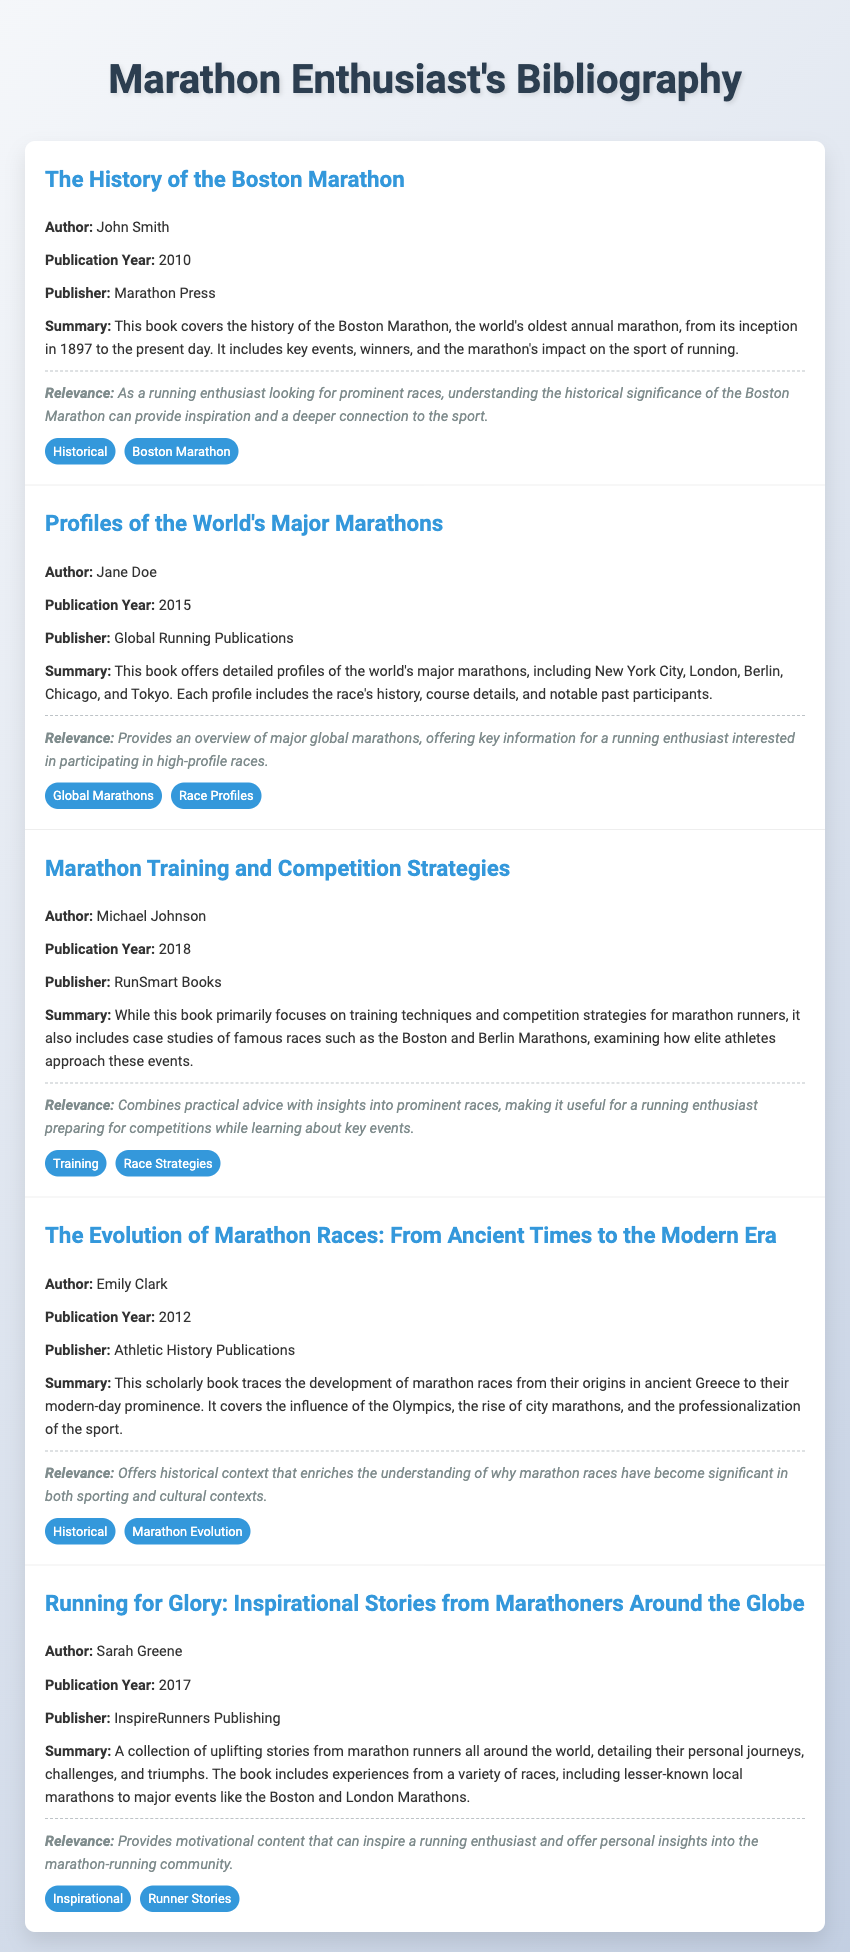What is the title of the first entry? The title of the first entry is found in the document, and it is "The History of the Boston Marathon."
Answer: The History of the Boston Marathon Who is the author of the book published in 2015? The author of the 2015 publication can be found in the second entry of the document, which lists Jane Doe as the author.
Answer: Jane Doe What year was "Marathon Training and Competition Strategies" published? The publication year of this book is explicitly mentioned in the document as 2018.
Answer: 2018 How many major marathons are detailed in "Profiles of the World's Major Marathons"? The document indicates that this book covers several major marathons but specifically mentions "New York City, London, Berlin, Chicago, and Tokyo," which counts as five.
Answer: Five What theme does "Running for Glory" focus on? The theme of this book is clearly indicated in the summary, focusing on personal journeys, challenges, and triumphs of marathon runners, thus it can be summarized as "Inspirational Stories."
Answer: Inspirational Stories Which entry discusses the evolution of marathons? The document specifies that "The Evolution of Marathon Races: From Ancient Times to the Modern Era" discusses the historical development of marathon races.
Answer: The Evolution of Marathon Races: From Ancient Times to the Modern Era What is the relevance of the book "Marathon Training and Competition Strategies"? The relevance section provides insights on how this book combines advice with insights into prominent races, making it relevant for preparation for competitions.
Answer: Useful for a running enthusiast preparing for competitions Who published "Running for Glory"? The document attributes the publication of "Running for Glory" to InspireRunners Publishing as stated under the publication information.
Answer: InspireRunners Publishing 